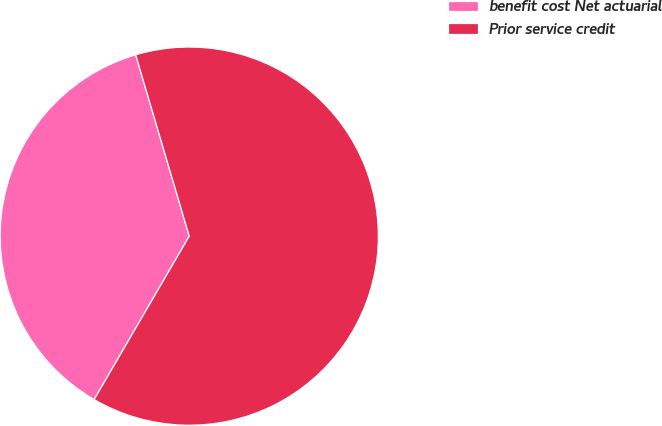<chart> <loc_0><loc_0><loc_500><loc_500><pie_chart><fcel>benefit cost Net actuarial<fcel>Prior service credit<nl><fcel>37.04%<fcel>62.96%<nl></chart> 